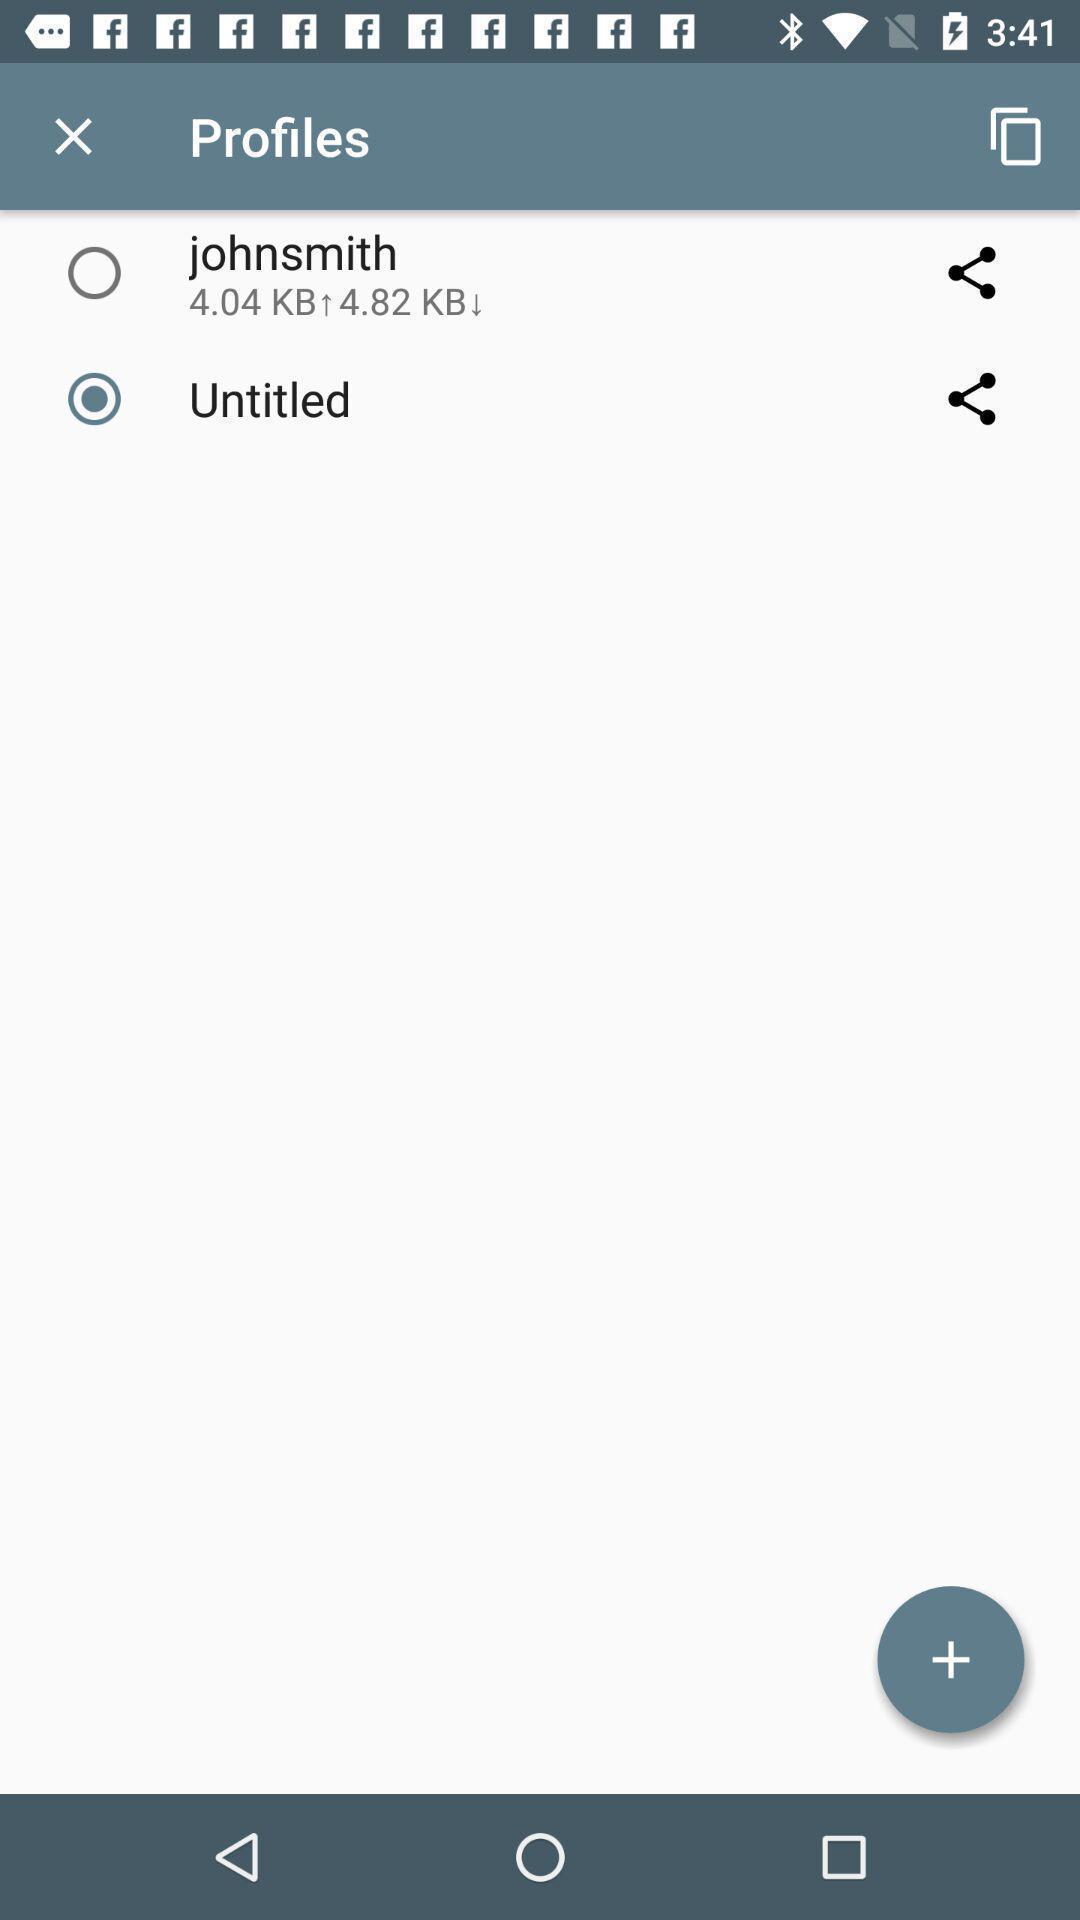What can you discern from this picture? Screen shows different profiles on a device. 